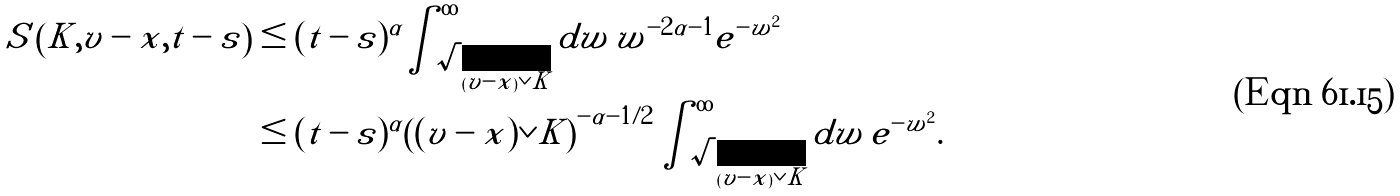Convert formula to latex. <formula><loc_0><loc_0><loc_500><loc_500>S \left ( K , v - x , t - s \right ) & \leq ( t - s ) ^ { \alpha } \int _ { \sqrt { ( v - x ) \vee K } } ^ { \infty } d w \, w ^ { - 2 \alpha - 1 } e ^ { - w ^ { 2 } } \\ & \leq ( t - s ) ^ { \alpha } \left ( ( v - x ) \vee K \right ) ^ { - \alpha - 1 / 2 } \int _ { \sqrt { ( v - x ) \vee K } } ^ { \infty } d w \, e ^ { - w ^ { 2 } } .</formula> 